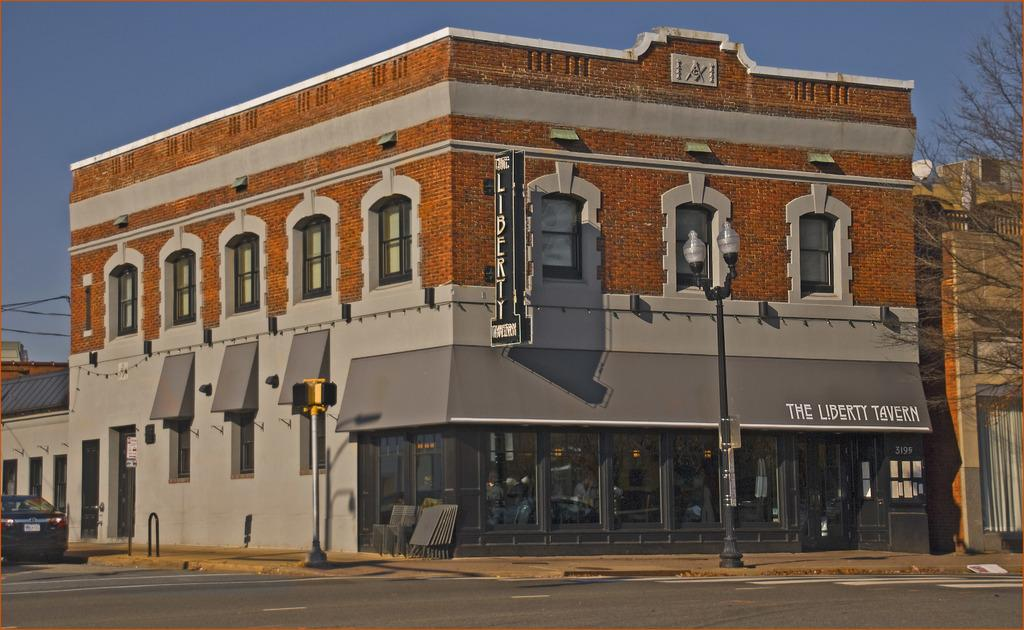What is the main structure in the middle of the picture? There is a building in the middle of the picture. What can be seen on the right side of the picture? There is a pole on the right side of the picture. How many lights are attached to the pole? Two lights are fixed to the pole. What is visible in the background of the picture? There is sky visible in the background of the picture. Can you tell me how fast the cart is moving in the image? There is no cart present in the image, so it is not possible to determine its speed. 